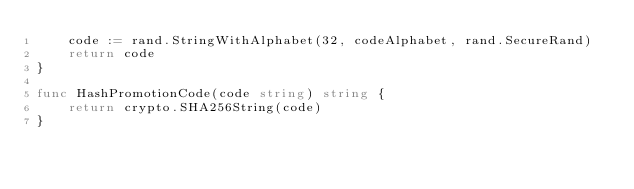<code> <loc_0><loc_0><loc_500><loc_500><_Go_>	code := rand.StringWithAlphabet(32, codeAlphabet, rand.SecureRand)
	return code
}

func HashPromotionCode(code string) string {
	return crypto.SHA256String(code)
}
</code> 